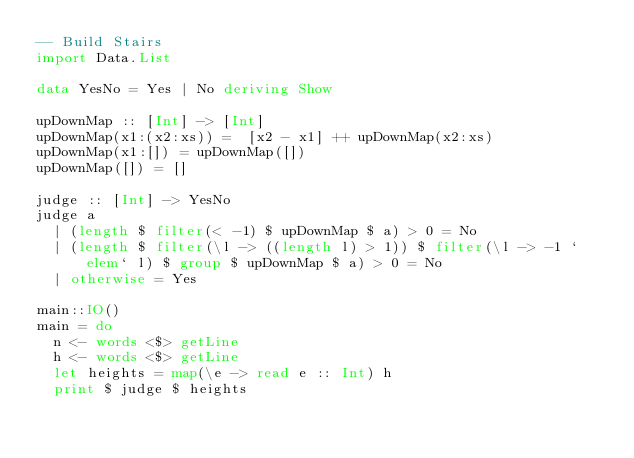Convert code to text. <code><loc_0><loc_0><loc_500><loc_500><_Haskell_>-- Build Stairs
import Data.List

data YesNo = Yes | No deriving Show

upDownMap :: [Int] -> [Int]
upDownMap(x1:(x2:xs)) =  [x2 - x1] ++ upDownMap(x2:xs)
upDownMap(x1:[]) = upDownMap([])
upDownMap([]) = []

judge :: [Int] -> YesNo
judge a
  | (length $ filter(< -1) $ upDownMap $ a) > 0 = No
  | (length $ filter(\l -> ((length l) > 1)) $ filter(\l -> -1 `elem` l) $ group $ upDownMap $ a) > 0 = No
  | otherwise = Yes

main::IO()
main = do
  n <- words <$> getLine
  h <- words <$> getLine
  let heights = map(\e -> read e :: Int) h
  print $ judge $ heights</code> 